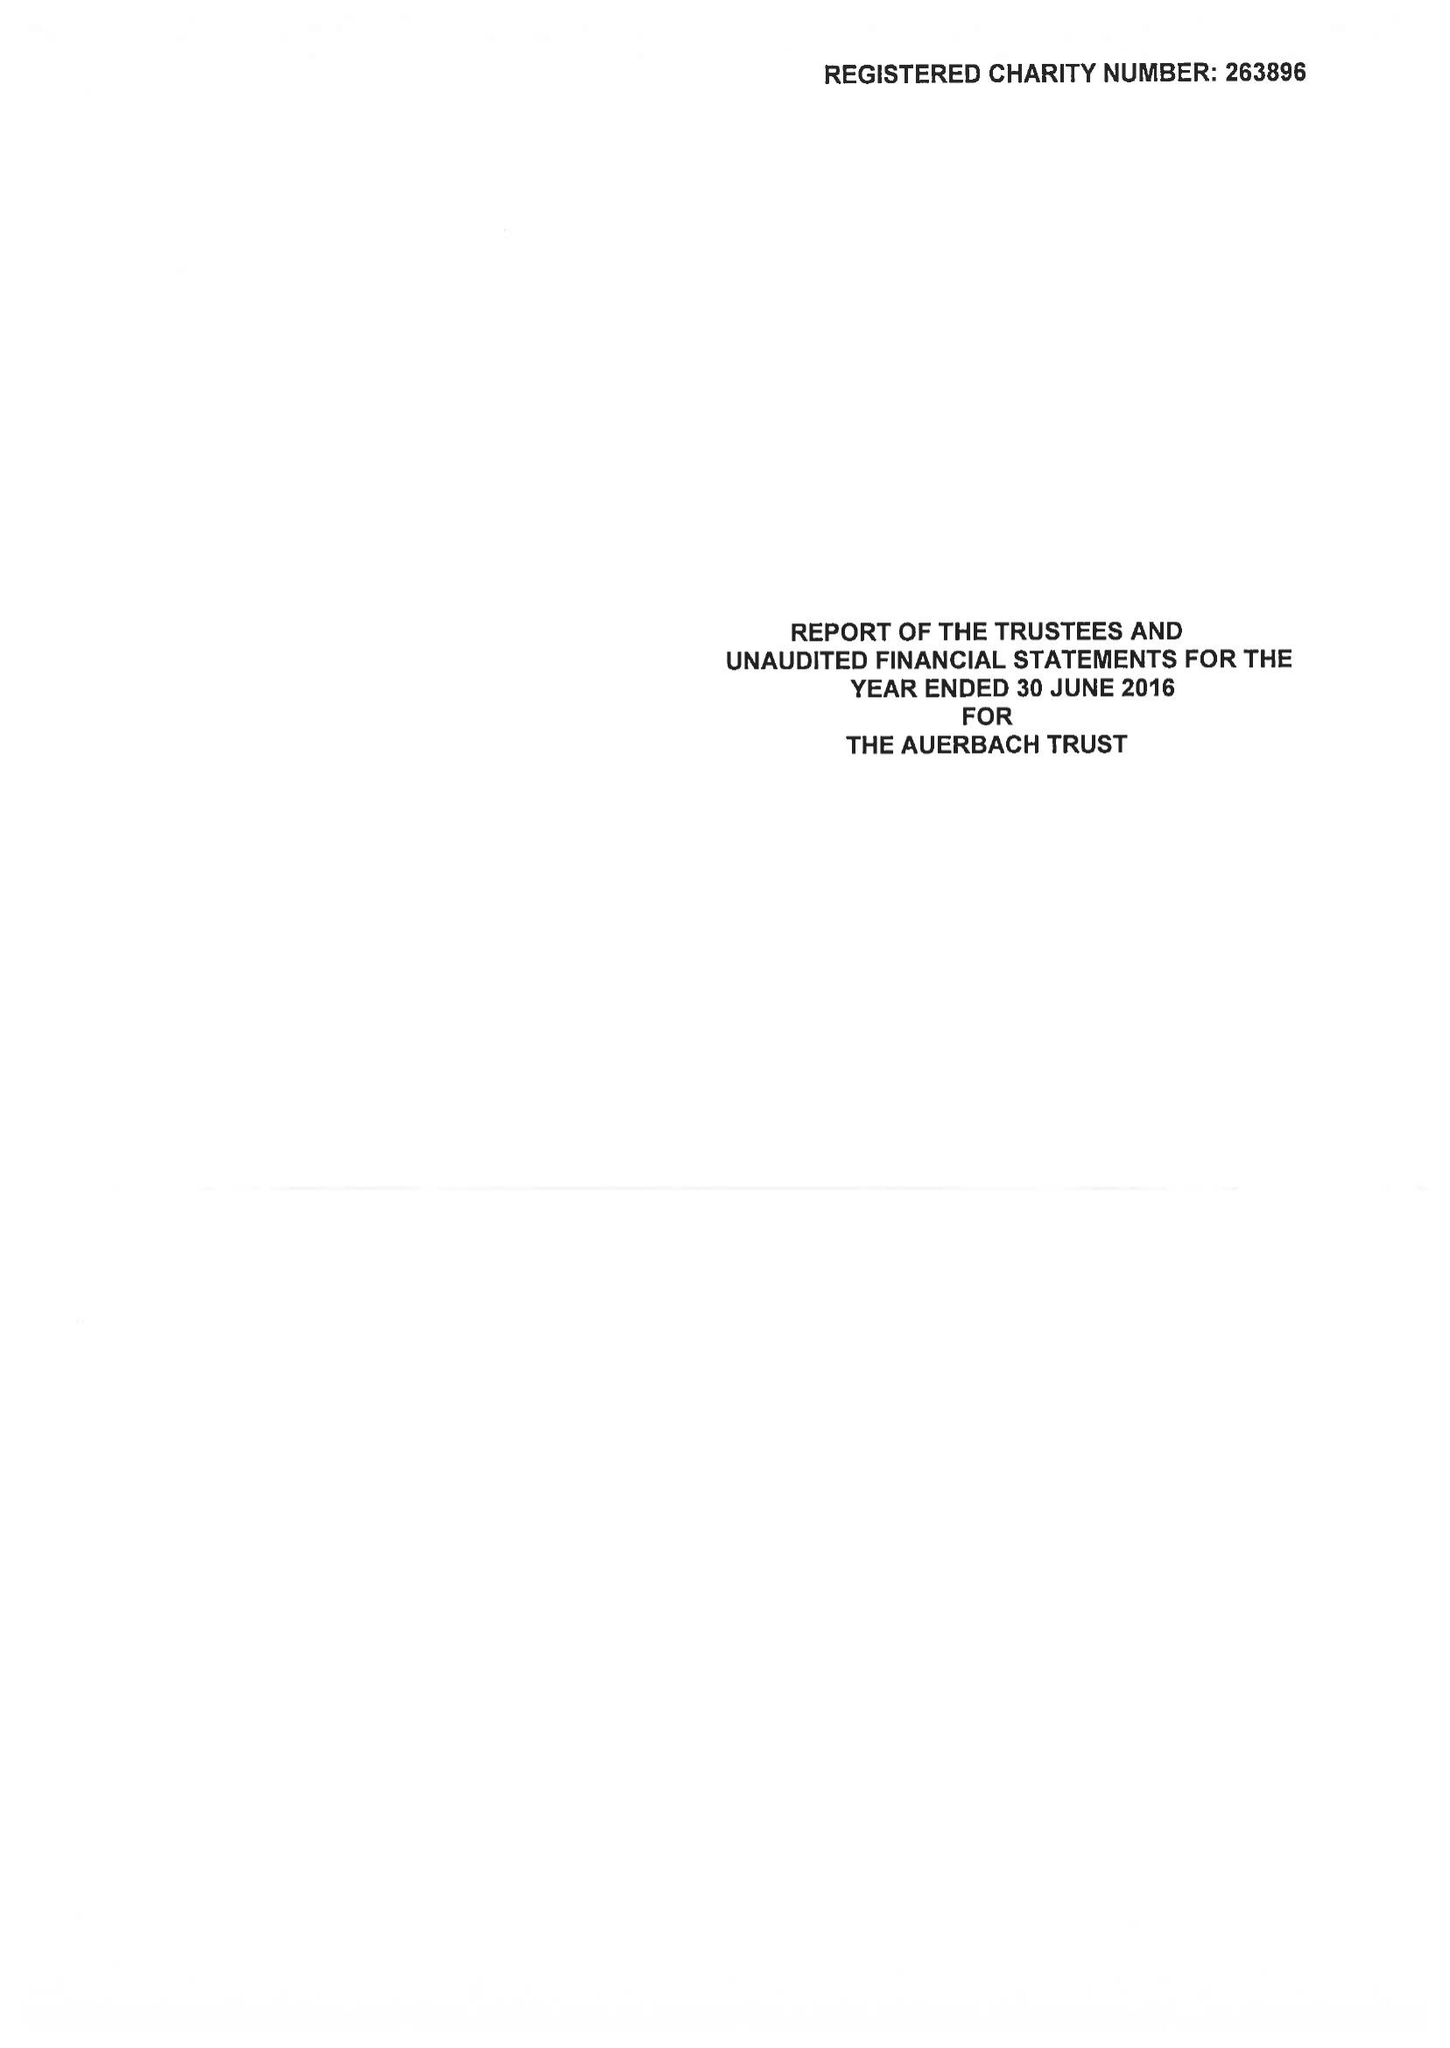What is the value for the address__street_line?
Answer the question using a single word or phrase. 21 CLARENCE TERRACE 